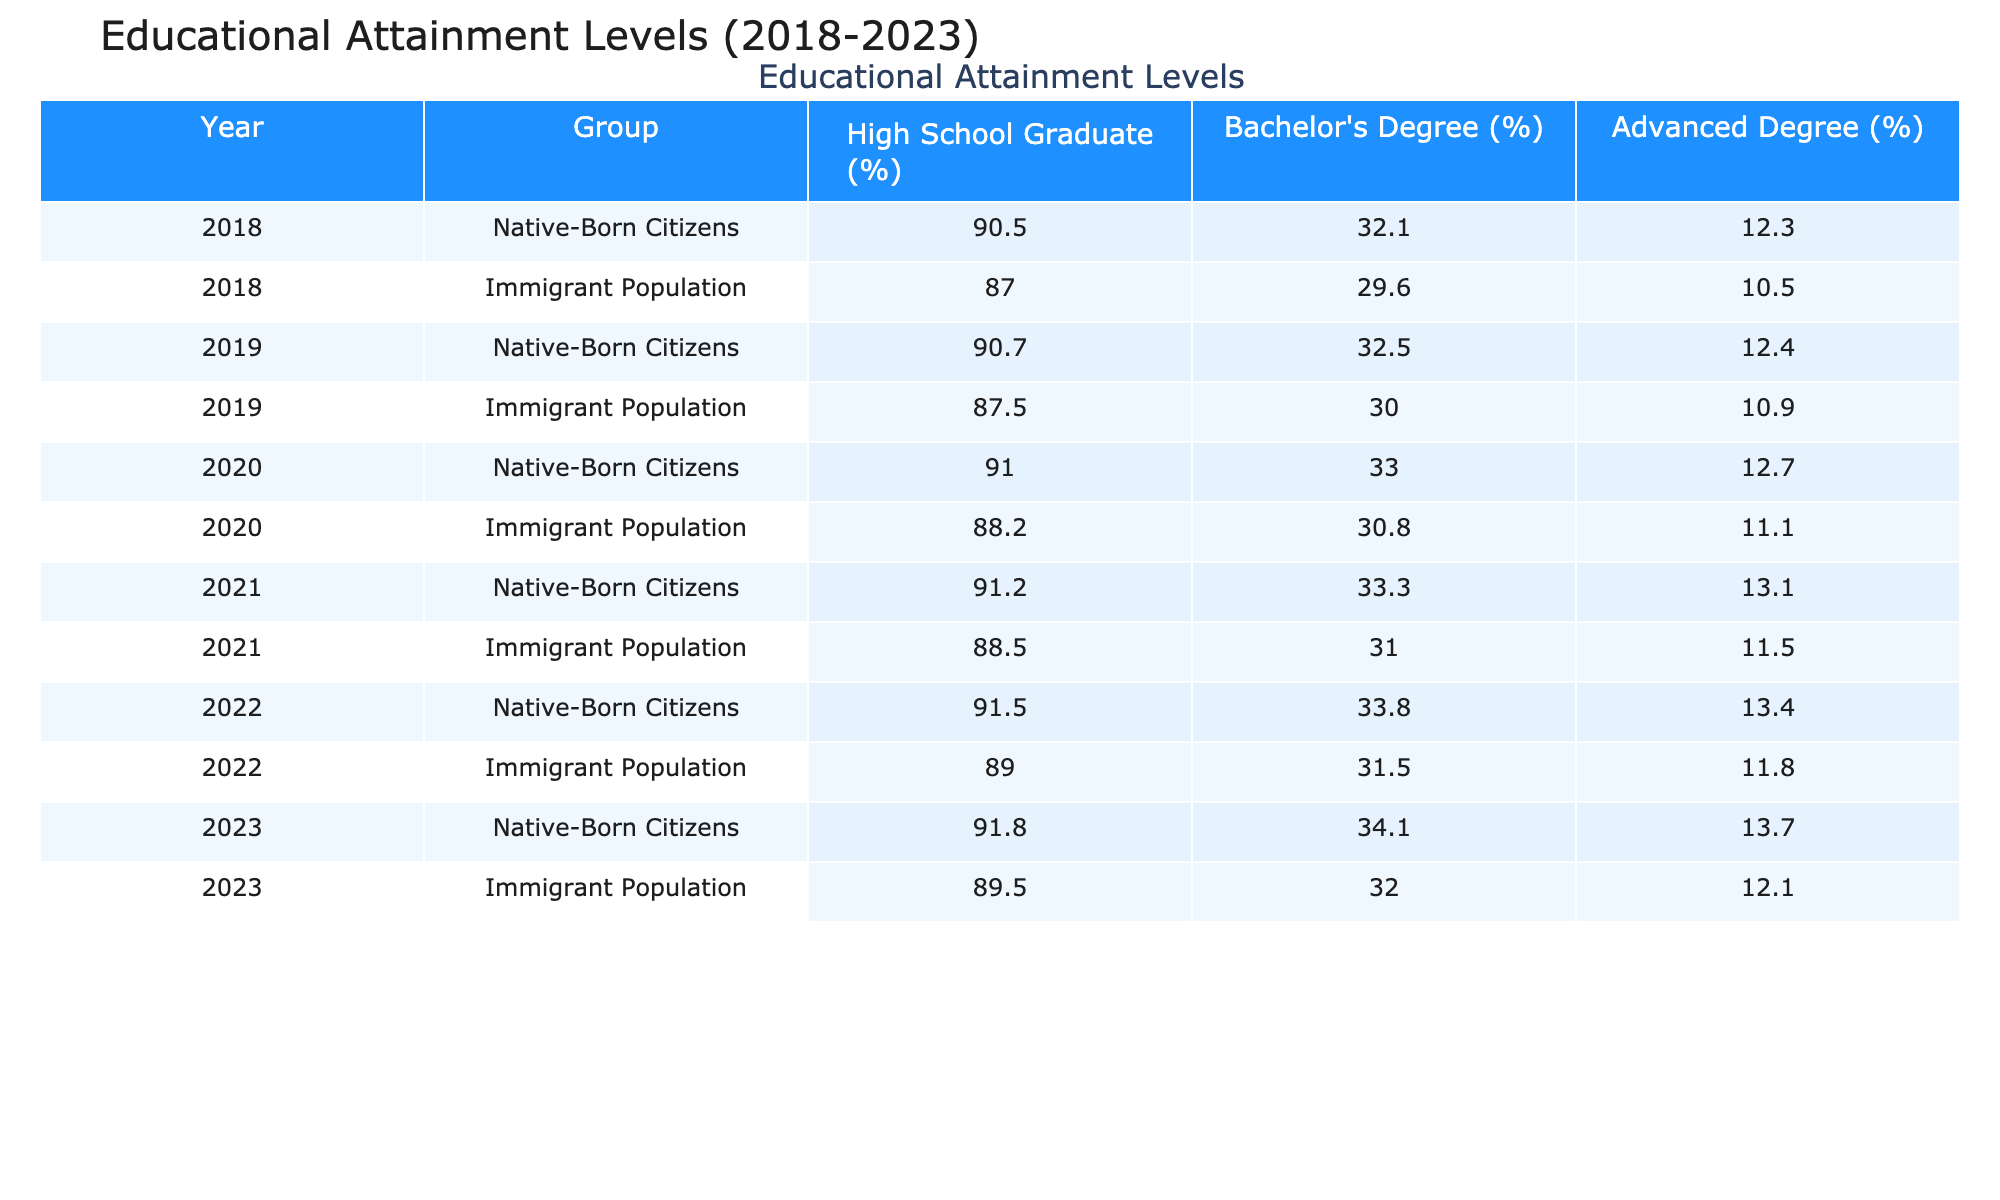What percentage of native-born citizens graduated high school in 2022? According to the table, the percentage of native-born citizens who graduated high school in 2022 is listed directly. It states that 91.5% of native-born citizens graduated high school that year.
Answer: 91.5% What has been the change in the percentage of immigrant population with a bachelor's degree from 2018 to 2023? The percentage of immigrants with a bachelor's degree in 2018 was 29.6%. In 2023, it increased to 32.0%. The change is calculated as 32.0% - 29.6% = 2.4%.
Answer: 2.4% Did the percentage of immigrant populations with advanced degrees increase from 2018 to 2023? In 2018, the percentage of immigrant populations with advanced degrees was 10.5%, and in 2023 it was 12.1%. Since 12.1% is greater than 10.5%, the percentage did indeed increase.
Answer: Yes Which group had a higher percentage of high school graduates in 2020? By comparing the figures directly from the table, native-born citizens had 91.0% while the immigrant population had 88.2% in 2020. Since 91.0% is higher than 88.2%, the native-born citizens had a higher percentage.
Answer: Native-born Citizens What is the average percentage of bachelor's degrees held by native-born citizens from 2018 to 2023? To find the average, we need to sum the percentages for each year (32.1 + 32.5 + 33.0 + 33.3 + 33.8 + 34.1) = 199.8, and then divide by the number of data points (6). Thus, the average is 199.8 / 6 = 33.3.
Answer: 33.3 Has the gap in high school graduation rates between native-born citizens and the immigrant population narrowed from 2018 to 2023? In 2018, the gap was 90.5% (native-born) - 87.0% (immigrant) = 3.5%. In 2023, the gap became 91.8% (native-born) - 89.5% (immigrant) = 2.3%. Since 2.3% is less than 3.5%, the gap has narrowed.
Answer: Yes What is the maximum percentage of advanced degrees achieved by native-born citizens over the years? Reviewing the table for native-born citizens, the percentage of advanced degrees reached its highest at 13.7% in 2023, as this figure is the highest among all years listed.
Answer: 13.7% What percentage of the immigrant population was a high school graduate in 2021? The table indicates that in 2021, 88.5% of the immigrant population graduated high school, which directly answers the question about that year.
Answer: 88.5% What was the overall trend in bachelor's degree attainment for the immigrant population from 2018 to 2023? Analyzing the data: 29.6% in 2018, 30.0% in 2019, 30.8% in 2020, 31.0% in 2021, 31.5% in 2022, and 32.0% in 2023 shows a consistent increase over the years. Hence, the overall trend is upward.
Answer: Upward 